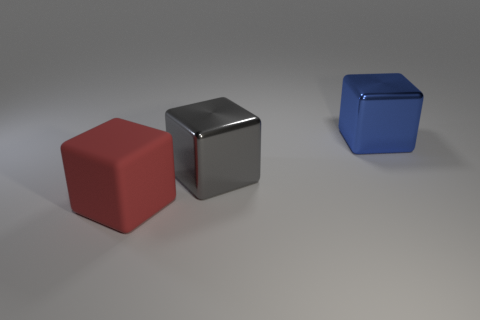There is a red cube that is the same size as the gray shiny cube; what is its material?
Provide a short and direct response. Rubber. What color is the rubber cube?
Your answer should be compact. Red. There is a large cube that is in front of the blue cube and behind the big red cube; what material is it?
Your answer should be very brief. Metal. There is a thing that is behind the large shiny cube on the left side of the big blue cube; are there any big matte cubes that are behind it?
Your answer should be compact. No. Are there any big gray metallic objects in front of the red cube?
Provide a succinct answer. No. What number of other objects are the same shape as the large red thing?
Ensure brevity in your answer.  2. What is the color of the other rubber thing that is the same size as the blue thing?
Offer a terse response. Red. Is the number of large red things in front of the red cube less than the number of large gray cubes right of the big gray metal block?
Offer a terse response. No. What number of blocks are to the right of the large shiny block that is to the left of the block that is behind the large gray thing?
Your answer should be very brief. 1. What size is the blue metallic thing that is the same shape as the large red thing?
Your answer should be compact. Large. 